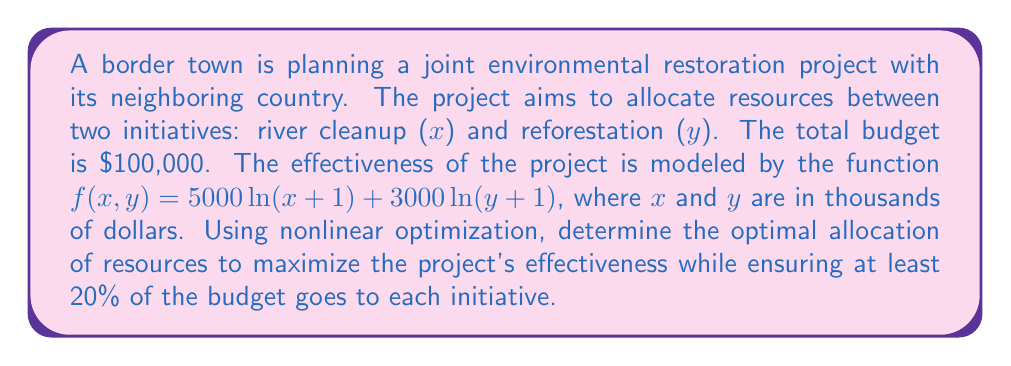Give your solution to this math problem. 1) We need to maximize $f(x,y) = 5000\ln(x+1) + 3000\ln(y+1)$ subject to the constraints:

   $x + y = 100$ (total budget constraint)
   $x \geq 20$, $y \geq 20$ (minimum allocation constraint)

2) This is a constrained optimization problem. We can use the method of Lagrange multipliers.

3) Define the Lagrangian function:
   $$L(x,y,\lambda) = 5000\ln(x+1) + 3000\ln(y+1) - \lambda(x+y-100)$$

4) Set partial derivatives to zero:
   $$\frac{\partial L}{\partial x} = \frac{5000}{x+1} - \lambda = 0$$
   $$\frac{\partial L}{\partial y} = \frac{3000}{y+1} - \lambda = 0$$
   $$\frac{\partial L}{\partial \lambda} = x + y - 100 = 0$$

5) From the first two equations:
   $$\frac{5000}{x+1} = \frac{3000}{y+1}$$

6) This implies:
   $$\frac{x+1}{y+1} = \frac{5}{3}$$

7) Solving this with the constraint $x + y = 100$:
   $$x = 62.5, y = 37.5$$

8) Check if this satisfies the minimum allocation constraint:
   Both $x$ and $y$ are greater than 20, so the constraint is satisfied.

9) Therefore, the optimal allocation is $x = 62.5$ thousand dollars for river cleanup and $y = 37.5$ thousand dollars for reforestation.
Answer: $62,500 for river cleanup, $37,500 for reforestation 